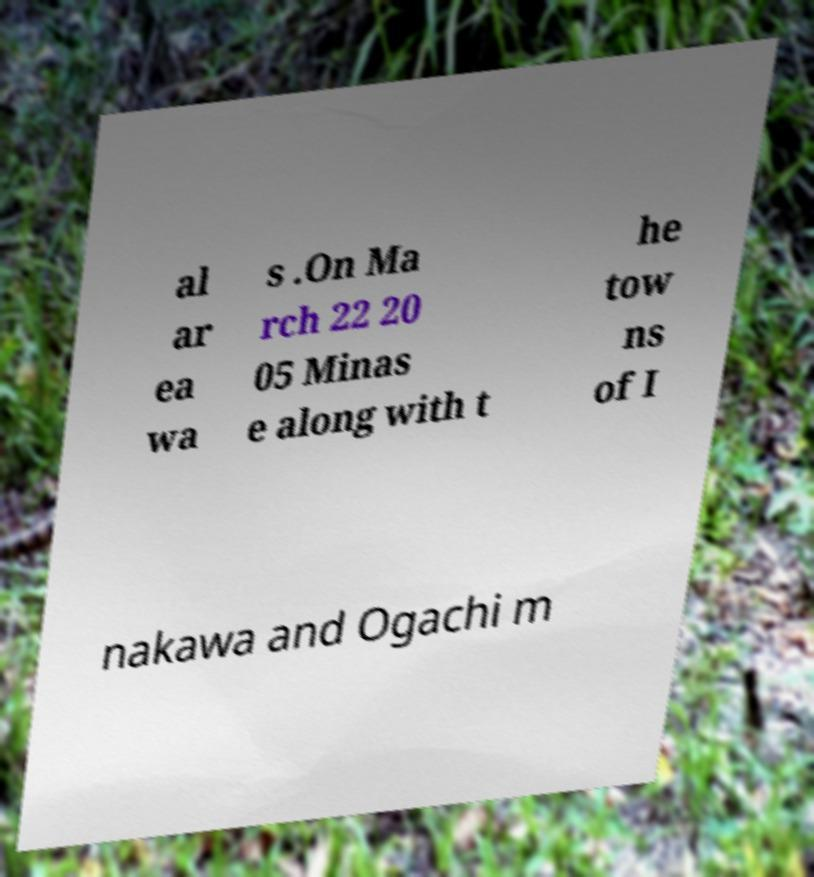Could you extract and type out the text from this image? al ar ea wa s .On Ma rch 22 20 05 Minas e along with t he tow ns of I nakawa and Ogachi m 